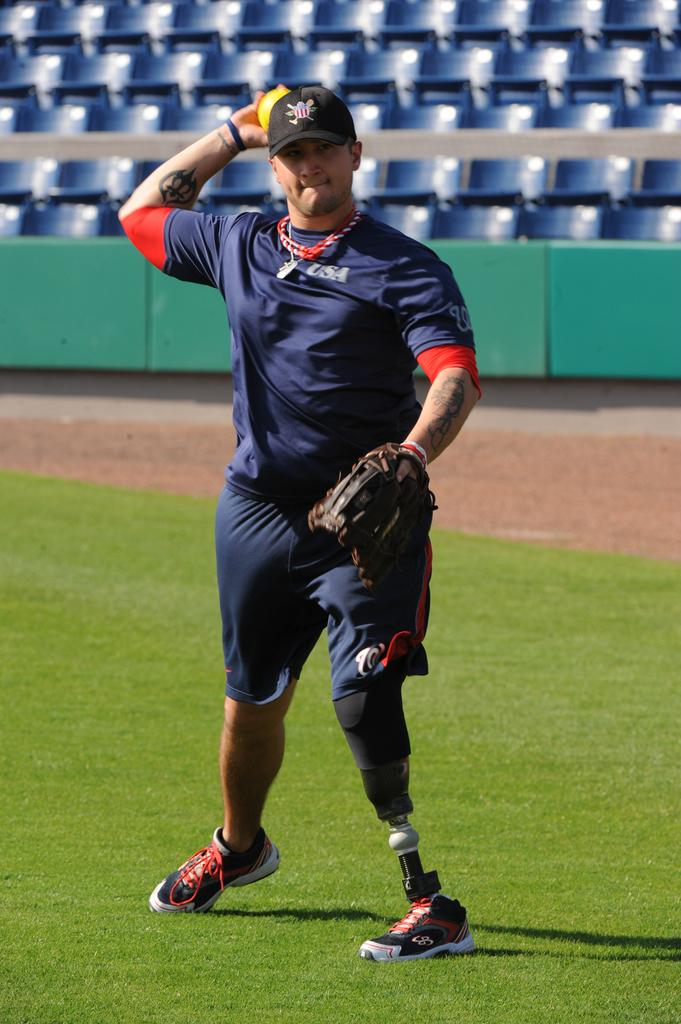What is the main subject of the image? The main subject of the image is a man. What is the man wearing on his hand? The man is wearing a glove. What is the man holding in the image? The man is holding a ball. What is the man standing on in the image? The man is standing on the ground. What type of vegetation is visible in the image? There is grass visible in the image. What type of furniture is present in the image? There are chairs in the image. What type of barrier is present in the image? There is a fence in the image. What type of army uniform is the man wearing in the image? There is no army uniform present in the image; the man is wearing a glove and holding a ball. What type of air conditioning unit is visible in the image? There is no air conditioning unit present in the image; the image features a man, a ball, a glove, grass, chairs, and a fence. 